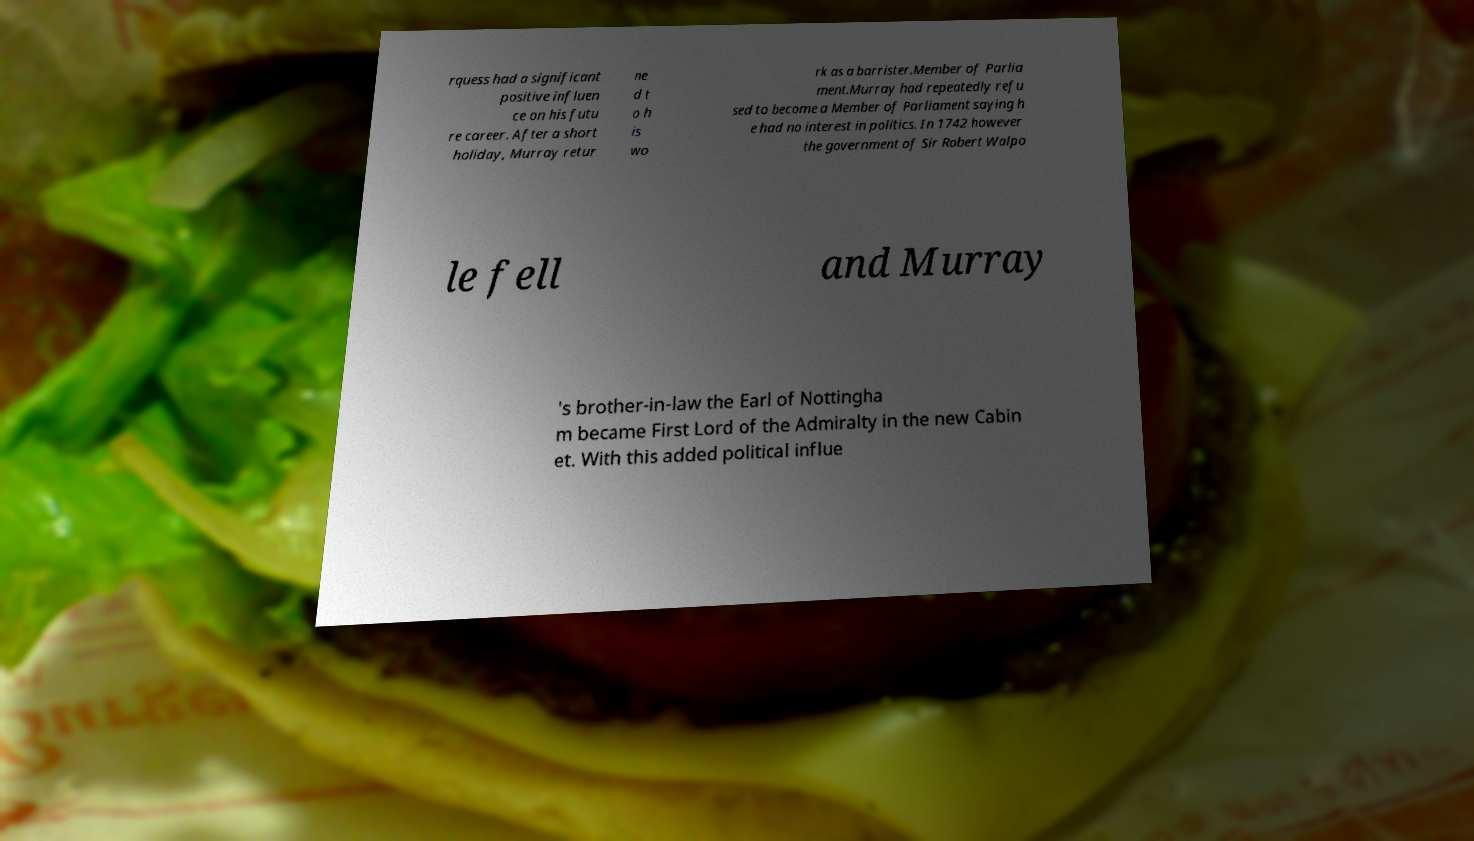Please read and relay the text visible in this image. What does it say? rquess had a significant positive influen ce on his futu re career. After a short holiday, Murray retur ne d t o h is wo rk as a barrister.Member of Parlia ment.Murray had repeatedly refu sed to become a Member of Parliament saying h e had no interest in politics. In 1742 however the government of Sir Robert Walpo le fell and Murray 's brother-in-law the Earl of Nottingha m became First Lord of the Admiralty in the new Cabin et. With this added political influe 